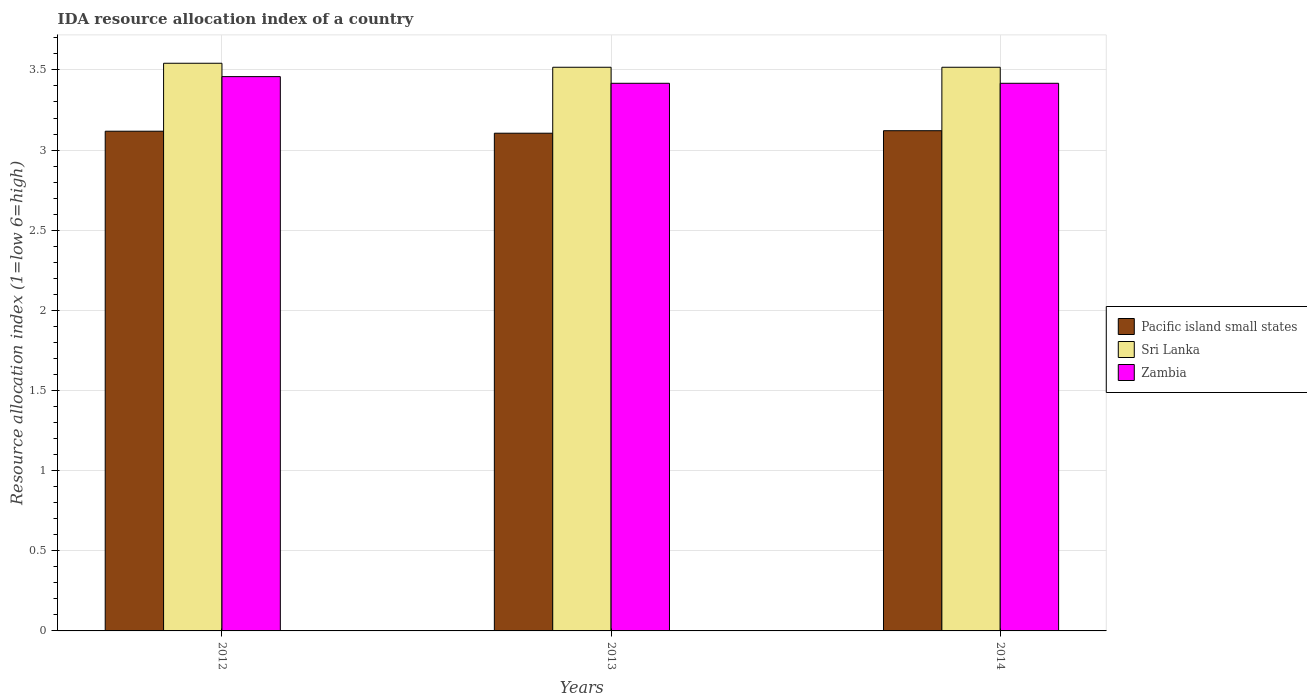How many bars are there on the 3rd tick from the left?
Keep it short and to the point. 3. How many bars are there on the 3rd tick from the right?
Ensure brevity in your answer.  3. What is the IDA resource allocation index in Zambia in 2012?
Offer a terse response. 3.46. Across all years, what is the maximum IDA resource allocation index in Pacific island small states?
Your response must be concise. 3.12. Across all years, what is the minimum IDA resource allocation index in Pacific island small states?
Keep it short and to the point. 3.11. In which year was the IDA resource allocation index in Sri Lanka maximum?
Give a very brief answer. 2012. In which year was the IDA resource allocation index in Zambia minimum?
Your answer should be compact. 2013. What is the total IDA resource allocation index in Sri Lanka in the graph?
Your answer should be very brief. 10.58. What is the difference between the IDA resource allocation index in Pacific island small states in 2012 and that in 2013?
Offer a terse response. 0.01. What is the difference between the IDA resource allocation index in Sri Lanka in 2014 and the IDA resource allocation index in Pacific island small states in 2012?
Give a very brief answer. 0.4. What is the average IDA resource allocation index in Sri Lanka per year?
Keep it short and to the point. 3.53. In the year 2012, what is the difference between the IDA resource allocation index in Zambia and IDA resource allocation index in Pacific island small states?
Keep it short and to the point. 0.34. What is the ratio of the IDA resource allocation index in Pacific island small states in 2012 to that in 2013?
Provide a short and direct response. 1. Is the difference between the IDA resource allocation index in Zambia in 2012 and 2013 greater than the difference between the IDA resource allocation index in Pacific island small states in 2012 and 2013?
Offer a very short reply. Yes. What is the difference between the highest and the second highest IDA resource allocation index in Pacific island small states?
Make the answer very short. 0. What is the difference between the highest and the lowest IDA resource allocation index in Pacific island small states?
Offer a very short reply. 0.02. Is the sum of the IDA resource allocation index in Zambia in 2013 and 2014 greater than the maximum IDA resource allocation index in Pacific island small states across all years?
Your response must be concise. Yes. What does the 3rd bar from the left in 2014 represents?
Make the answer very short. Zambia. What does the 3rd bar from the right in 2014 represents?
Your answer should be very brief. Pacific island small states. How many bars are there?
Give a very brief answer. 9. Are all the bars in the graph horizontal?
Ensure brevity in your answer.  No. What is the difference between two consecutive major ticks on the Y-axis?
Your answer should be very brief. 0.5. Are the values on the major ticks of Y-axis written in scientific E-notation?
Ensure brevity in your answer.  No. Does the graph contain any zero values?
Offer a very short reply. No. Does the graph contain grids?
Give a very brief answer. Yes. How many legend labels are there?
Keep it short and to the point. 3. What is the title of the graph?
Ensure brevity in your answer.  IDA resource allocation index of a country. What is the label or title of the X-axis?
Offer a very short reply. Years. What is the label or title of the Y-axis?
Give a very brief answer. Resource allocation index (1=low 6=high). What is the Resource allocation index (1=low 6=high) in Pacific island small states in 2012?
Offer a very short reply. 3.12. What is the Resource allocation index (1=low 6=high) of Sri Lanka in 2012?
Your response must be concise. 3.54. What is the Resource allocation index (1=low 6=high) in Zambia in 2012?
Keep it short and to the point. 3.46. What is the Resource allocation index (1=low 6=high) of Pacific island small states in 2013?
Give a very brief answer. 3.11. What is the Resource allocation index (1=low 6=high) of Sri Lanka in 2013?
Provide a short and direct response. 3.52. What is the Resource allocation index (1=low 6=high) of Zambia in 2013?
Your answer should be compact. 3.42. What is the Resource allocation index (1=low 6=high) of Pacific island small states in 2014?
Provide a succinct answer. 3.12. What is the Resource allocation index (1=low 6=high) of Sri Lanka in 2014?
Make the answer very short. 3.52. What is the Resource allocation index (1=low 6=high) in Zambia in 2014?
Your answer should be compact. 3.42. Across all years, what is the maximum Resource allocation index (1=low 6=high) of Pacific island small states?
Offer a very short reply. 3.12. Across all years, what is the maximum Resource allocation index (1=low 6=high) of Sri Lanka?
Your answer should be compact. 3.54. Across all years, what is the maximum Resource allocation index (1=low 6=high) of Zambia?
Ensure brevity in your answer.  3.46. Across all years, what is the minimum Resource allocation index (1=low 6=high) of Pacific island small states?
Provide a short and direct response. 3.11. Across all years, what is the minimum Resource allocation index (1=low 6=high) of Sri Lanka?
Offer a very short reply. 3.52. Across all years, what is the minimum Resource allocation index (1=low 6=high) of Zambia?
Provide a succinct answer. 3.42. What is the total Resource allocation index (1=low 6=high) in Pacific island small states in the graph?
Your response must be concise. 9.34. What is the total Resource allocation index (1=low 6=high) of Sri Lanka in the graph?
Provide a succinct answer. 10.57. What is the total Resource allocation index (1=low 6=high) in Zambia in the graph?
Your answer should be very brief. 10.29. What is the difference between the Resource allocation index (1=low 6=high) of Pacific island small states in 2012 and that in 2013?
Your response must be concise. 0.01. What is the difference between the Resource allocation index (1=low 6=high) of Sri Lanka in 2012 and that in 2013?
Provide a short and direct response. 0.03. What is the difference between the Resource allocation index (1=low 6=high) of Zambia in 2012 and that in 2013?
Give a very brief answer. 0.04. What is the difference between the Resource allocation index (1=low 6=high) of Pacific island small states in 2012 and that in 2014?
Provide a short and direct response. -0. What is the difference between the Resource allocation index (1=low 6=high) of Sri Lanka in 2012 and that in 2014?
Provide a succinct answer. 0.03. What is the difference between the Resource allocation index (1=low 6=high) of Zambia in 2012 and that in 2014?
Make the answer very short. 0.04. What is the difference between the Resource allocation index (1=low 6=high) of Pacific island small states in 2013 and that in 2014?
Offer a very short reply. -0.02. What is the difference between the Resource allocation index (1=low 6=high) of Zambia in 2013 and that in 2014?
Keep it short and to the point. -0. What is the difference between the Resource allocation index (1=low 6=high) of Pacific island small states in 2012 and the Resource allocation index (1=low 6=high) of Sri Lanka in 2013?
Keep it short and to the point. -0.4. What is the difference between the Resource allocation index (1=low 6=high) of Pacific island small states in 2012 and the Resource allocation index (1=low 6=high) of Zambia in 2013?
Your response must be concise. -0.3. What is the difference between the Resource allocation index (1=low 6=high) in Pacific island small states in 2012 and the Resource allocation index (1=low 6=high) in Sri Lanka in 2014?
Keep it short and to the point. -0.4. What is the difference between the Resource allocation index (1=low 6=high) in Pacific island small states in 2012 and the Resource allocation index (1=low 6=high) in Zambia in 2014?
Your answer should be very brief. -0.3. What is the difference between the Resource allocation index (1=low 6=high) of Pacific island small states in 2013 and the Resource allocation index (1=low 6=high) of Sri Lanka in 2014?
Give a very brief answer. -0.41. What is the difference between the Resource allocation index (1=low 6=high) of Pacific island small states in 2013 and the Resource allocation index (1=low 6=high) of Zambia in 2014?
Make the answer very short. -0.31. What is the average Resource allocation index (1=low 6=high) of Pacific island small states per year?
Make the answer very short. 3.11. What is the average Resource allocation index (1=low 6=high) of Sri Lanka per year?
Give a very brief answer. 3.52. What is the average Resource allocation index (1=low 6=high) of Zambia per year?
Provide a succinct answer. 3.43. In the year 2012, what is the difference between the Resource allocation index (1=low 6=high) of Pacific island small states and Resource allocation index (1=low 6=high) of Sri Lanka?
Keep it short and to the point. -0.42. In the year 2012, what is the difference between the Resource allocation index (1=low 6=high) in Pacific island small states and Resource allocation index (1=low 6=high) in Zambia?
Provide a short and direct response. -0.34. In the year 2012, what is the difference between the Resource allocation index (1=low 6=high) of Sri Lanka and Resource allocation index (1=low 6=high) of Zambia?
Offer a very short reply. 0.08. In the year 2013, what is the difference between the Resource allocation index (1=low 6=high) in Pacific island small states and Resource allocation index (1=low 6=high) in Sri Lanka?
Your answer should be very brief. -0.41. In the year 2013, what is the difference between the Resource allocation index (1=low 6=high) in Pacific island small states and Resource allocation index (1=low 6=high) in Zambia?
Provide a short and direct response. -0.31. In the year 2013, what is the difference between the Resource allocation index (1=low 6=high) of Sri Lanka and Resource allocation index (1=low 6=high) of Zambia?
Keep it short and to the point. 0.1. In the year 2014, what is the difference between the Resource allocation index (1=low 6=high) of Pacific island small states and Resource allocation index (1=low 6=high) of Sri Lanka?
Your response must be concise. -0.4. In the year 2014, what is the difference between the Resource allocation index (1=low 6=high) of Pacific island small states and Resource allocation index (1=low 6=high) of Zambia?
Give a very brief answer. -0.3. In the year 2014, what is the difference between the Resource allocation index (1=low 6=high) of Sri Lanka and Resource allocation index (1=low 6=high) of Zambia?
Keep it short and to the point. 0.1. What is the ratio of the Resource allocation index (1=low 6=high) in Sri Lanka in 2012 to that in 2013?
Provide a succinct answer. 1.01. What is the ratio of the Resource allocation index (1=low 6=high) in Zambia in 2012 to that in 2013?
Offer a terse response. 1.01. What is the ratio of the Resource allocation index (1=low 6=high) of Pacific island small states in 2012 to that in 2014?
Give a very brief answer. 1. What is the ratio of the Resource allocation index (1=low 6=high) of Sri Lanka in 2012 to that in 2014?
Make the answer very short. 1.01. What is the ratio of the Resource allocation index (1=low 6=high) of Zambia in 2012 to that in 2014?
Ensure brevity in your answer.  1.01. What is the ratio of the Resource allocation index (1=low 6=high) of Pacific island small states in 2013 to that in 2014?
Ensure brevity in your answer.  0.99. What is the ratio of the Resource allocation index (1=low 6=high) in Zambia in 2013 to that in 2014?
Offer a very short reply. 1. What is the difference between the highest and the second highest Resource allocation index (1=low 6=high) of Pacific island small states?
Your answer should be very brief. 0. What is the difference between the highest and the second highest Resource allocation index (1=low 6=high) in Sri Lanka?
Provide a succinct answer. 0.03. What is the difference between the highest and the second highest Resource allocation index (1=low 6=high) of Zambia?
Offer a very short reply. 0.04. What is the difference between the highest and the lowest Resource allocation index (1=low 6=high) of Pacific island small states?
Offer a terse response. 0.02. What is the difference between the highest and the lowest Resource allocation index (1=low 6=high) of Sri Lanka?
Make the answer very short. 0.03. What is the difference between the highest and the lowest Resource allocation index (1=low 6=high) of Zambia?
Your response must be concise. 0.04. 